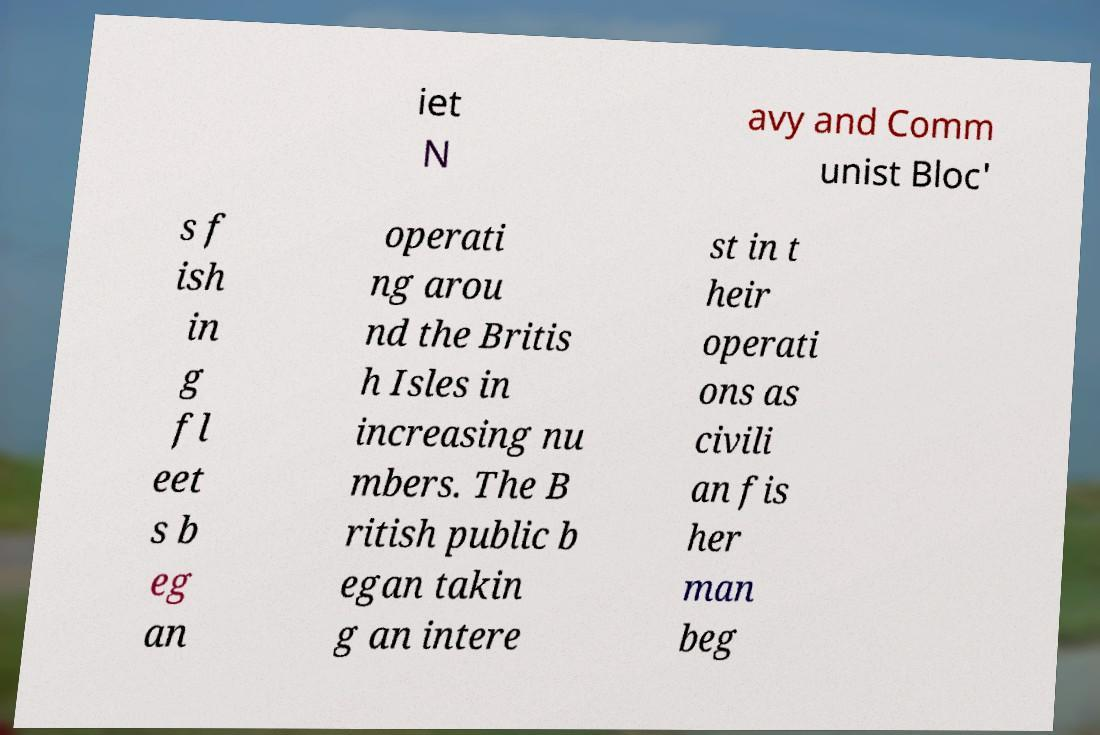Can you accurately transcribe the text from the provided image for me? iet N avy and Comm unist Bloc' s f ish in g fl eet s b eg an operati ng arou nd the Britis h Isles in increasing nu mbers. The B ritish public b egan takin g an intere st in t heir operati ons as civili an fis her man beg 